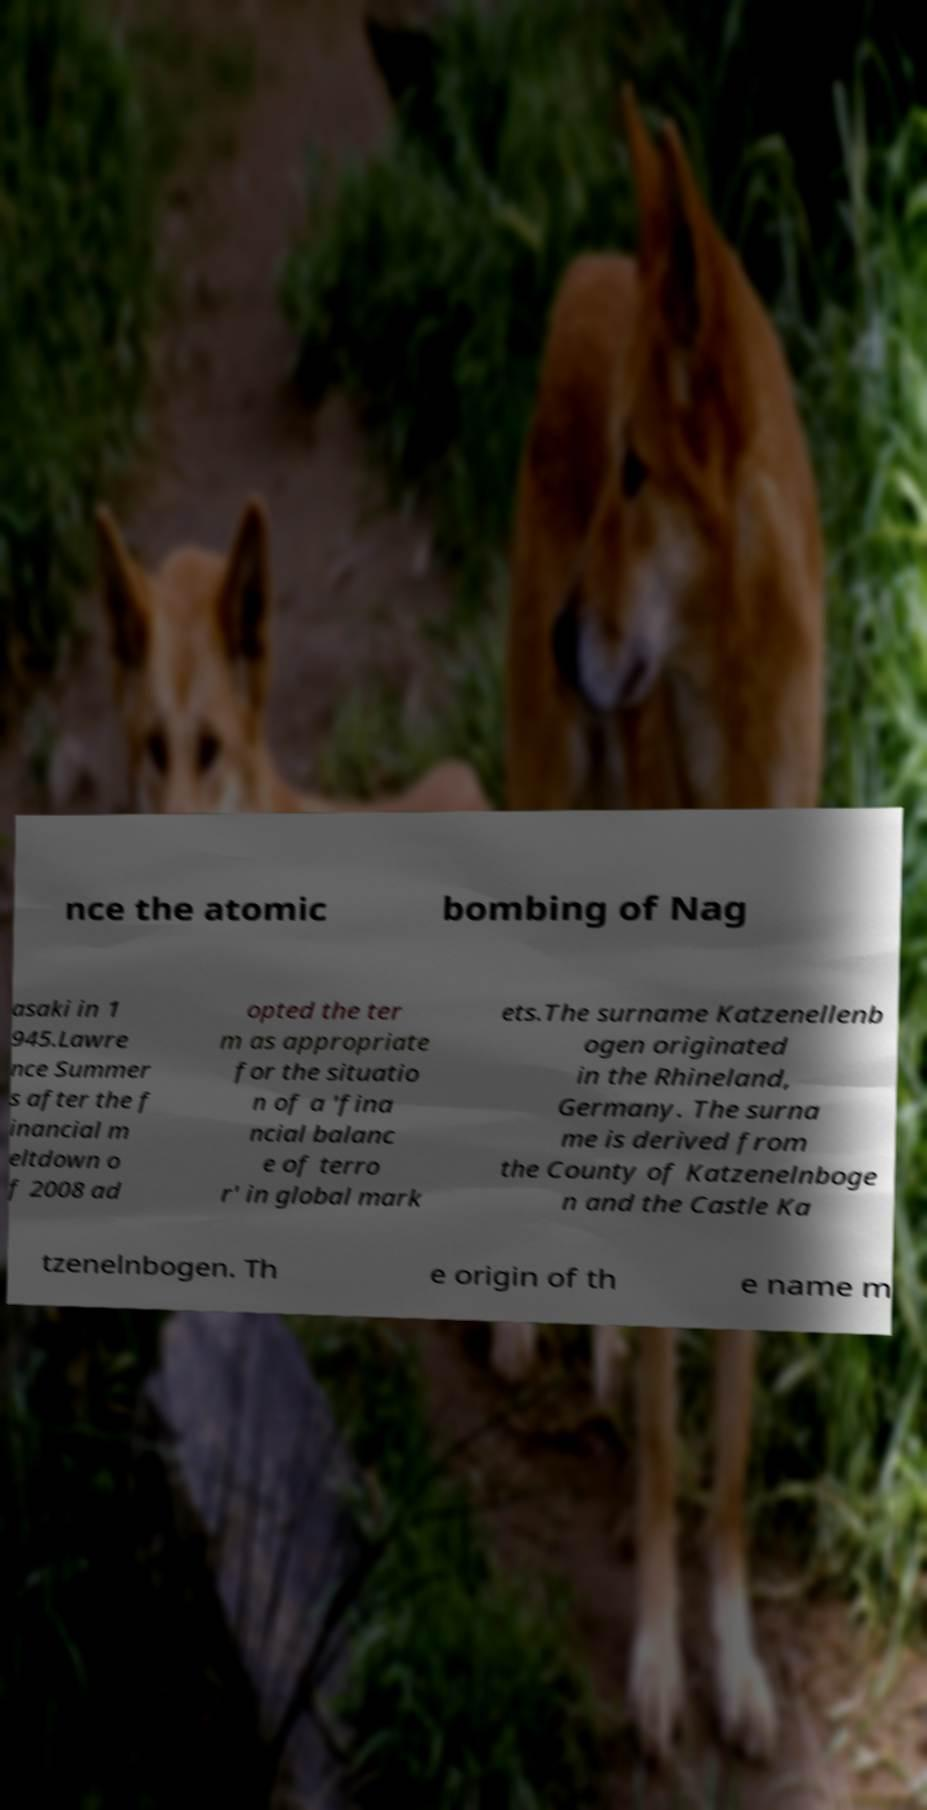What messages or text are displayed in this image? I need them in a readable, typed format. nce the atomic bombing of Nag asaki in 1 945.Lawre nce Summer s after the f inancial m eltdown o f 2008 ad opted the ter m as appropriate for the situatio n of a 'fina ncial balanc e of terro r' in global mark ets.The surname Katzenellenb ogen originated in the Rhineland, Germany. The surna me is derived from the County of Katzenelnboge n and the Castle Ka tzenelnbogen. Th e origin of th e name m 